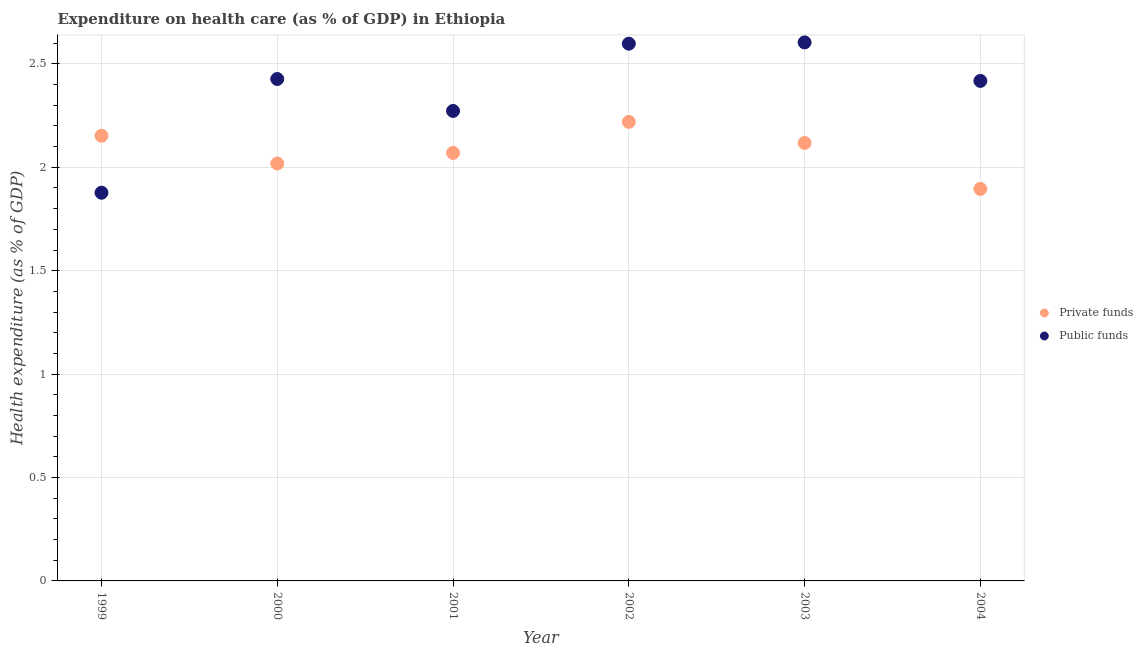Is the number of dotlines equal to the number of legend labels?
Provide a short and direct response. Yes. What is the amount of private funds spent in healthcare in 2003?
Your response must be concise. 2.12. Across all years, what is the maximum amount of private funds spent in healthcare?
Provide a short and direct response. 2.22. Across all years, what is the minimum amount of private funds spent in healthcare?
Your response must be concise. 1.9. In which year was the amount of private funds spent in healthcare maximum?
Offer a terse response. 2002. What is the total amount of private funds spent in healthcare in the graph?
Your answer should be compact. 12.47. What is the difference between the amount of private funds spent in healthcare in 1999 and that in 2004?
Keep it short and to the point. 0.26. What is the difference between the amount of public funds spent in healthcare in 2001 and the amount of private funds spent in healthcare in 2000?
Provide a succinct answer. 0.25. What is the average amount of private funds spent in healthcare per year?
Keep it short and to the point. 2.08. In the year 2002, what is the difference between the amount of public funds spent in healthcare and amount of private funds spent in healthcare?
Offer a very short reply. 0.38. What is the ratio of the amount of private funds spent in healthcare in 1999 to that in 2001?
Offer a terse response. 1.04. What is the difference between the highest and the second highest amount of private funds spent in healthcare?
Keep it short and to the point. 0.07. What is the difference between the highest and the lowest amount of private funds spent in healthcare?
Your response must be concise. 0.32. In how many years, is the amount of private funds spent in healthcare greater than the average amount of private funds spent in healthcare taken over all years?
Offer a terse response. 3. Is the sum of the amount of private funds spent in healthcare in 2001 and 2002 greater than the maximum amount of public funds spent in healthcare across all years?
Your answer should be very brief. Yes. Does the amount of private funds spent in healthcare monotonically increase over the years?
Offer a terse response. No. What is the difference between two consecutive major ticks on the Y-axis?
Offer a very short reply. 0.5. Does the graph contain grids?
Offer a terse response. Yes. How are the legend labels stacked?
Provide a succinct answer. Vertical. What is the title of the graph?
Offer a terse response. Expenditure on health care (as % of GDP) in Ethiopia. Does "Primary education" appear as one of the legend labels in the graph?
Provide a succinct answer. No. What is the label or title of the X-axis?
Keep it short and to the point. Year. What is the label or title of the Y-axis?
Offer a terse response. Health expenditure (as % of GDP). What is the Health expenditure (as % of GDP) of Private funds in 1999?
Offer a terse response. 2.15. What is the Health expenditure (as % of GDP) in Public funds in 1999?
Your response must be concise. 1.88. What is the Health expenditure (as % of GDP) in Private funds in 2000?
Keep it short and to the point. 2.02. What is the Health expenditure (as % of GDP) in Public funds in 2000?
Make the answer very short. 2.43. What is the Health expenditure (as % of GDP) in Private funds in 2001?
Your response must be concise. 2.07. What is the Health expenditure (as % of GDP) in Public funds in 2001?
Give a very brief answer. 2.27. What is the Health expenditure (as % of GDP) in Private funds in 2002?
Provide a short and direct response. 2.22. What is the Health expenditure (as % of GDP) of Public funds in 2002?
Provide a succinct answer. 2.6. What is the Health expenditure (as % of GDP) of Private funds in 2003?
Ensure brevity in your answer.  2.12. What is the Health expenditure (as % of GDP) in Public funds in 2003?
Provide a succinct answer. 2.6. What is the Health expenditure (as % of GDP) of Private funds in 2004?
Your answer should be compact. 1.9. What is the Health expenditure (as % of GDP) in Public funds in 2004?
Your response must be concise. 2.42. Across all years, what is the maximum Health expenditure (as % of GDP) in Private funds?
Your answer should be compact. 2.22. Across all years, what is the maximum Health expenditure (as % of GDP) of Public funds?
Your response must be concise. 2.6. Across all years, what is the minimum Health expenditure (as % of GDP) of Private funds?
Keep it short and to the point. 1.9. Across all years, what is the minimum Health expenditure (as % of GDP) of Public funds?
Provide a succinct answer. 1.88. What is the total Health expenditure (as % of GDP) in Private funds in the graph?
Provide a short and direct response. 12.47. What is the total Health expenditure (as % of GDP) in Public funds in the graph?
Offer a terse response. 14.2. What is the difference between the Health expenditure (as % of GDP) of Private funds in 1999 and that in 2000?
Provide a short and direct response. 0.13. What is the difference between the Health expenditure (as % of GDP) of Public funds in 1999 and that in 2000?
Provide a succinct answer. -0.55. What is the difference between the Health expenditure (as % of GDP) in Private funds in 1999 and that in 2001?
Provide a short and direct response. 0.08. What is the difference between the Health expenditure (as % of GDP) in Public funds in 1999 and that in 2001?
Keep it short and to the point. -0.4. What is the difference between the Health expenditure (as % of GDP) in Private funds in 1999 and that in 2002?
Your answer should be very brief. -0.07. What is the difference between the Health expenditure (as % of GDP) in Public funds in 1999 and that in 2002?
Your answer should be very brief. -0.72. What is the difference between the Health expenditure (as % of GDP) in Private funds in 1999 and that in 2003?
Provide a succinct answer. 0.03. What is the difference between the Health expenditure (as % of GDP) of Public funds in 1999 and that in 2003?
Your response must be concise. -0.73. What is the difference between the Health expenditure (as % of GDP) in Private funds in 1999 and that in 2004?
Your answer should be very brief. 0.26. What is the difference between the Health expenditure (as % of GDP) in Public funds in 1999 and that in 2004?
Your answer should be compact. -0.54. What is the difference between the Health expenditure (as % of GDP) of Private funds in 2000 and that in 2001?
Offer a terse response. -0.05. What is the difference between the Health expenditure (as % of GDP) of Public funds in 2000 and that in 2001?
Your response must be concise. 0.15. What is the difference between the Health expenditure (as % of GDP) of Private funds in 2000 and that in 2002?
Ensure brevity in your answer.  -0.2. What is the difference between the Health expenditure (as % of GDP) of Public funds in 2000 and that in 2002?
Offer a very short reply. -0.17. What is the difference between the Health expenditure (as % of GDP) of Private funds in 2000 and that in 2003?
Give a very brief answer. -0.1. What is the difference between the Health expenditure (as % of GDP) of Public funds in 2000 and that in 2003?
Make the answer very short. -0.18. What is the difference between the Health expenditure (as % of GDP) of Private funds in 2000 and that in 2004?
Make the answer very short. 0.12. What is the difference between the Health expenditure (as % of GDP) of Public funds in 2000 and that in 2004?
Provide a succinct answer. 0.01. What is the difference between the Health expenditure (as % of GDP) of Public funds in 2001 and that in 2002?
Offer a very short reply. -0.33. What is the difference between the Health expenditure (as % of GDP) of Private funds in 2001 and that in 2003?
Offer a very short reply. -0.05. What is the difference between the Health expenditure (as % of GDP) of Public funds in 2001 and that in 2003?
Provide a succinct answer. -0.33. What is the difference between the Health expenditure (as % of GDP) in Private funds in 2001 and that in 2004?
Give a very brief answer. 0.17. What is the difference between the Health expenditure (as % of GDP) of Public funds in 2001 and that in 2004?
Provide a short and direct response. -0.15. What is the difference between the Health expenditure (as % of GDP) in Private funds in 2002 and that in 2003?
Provide a short and direct response. 0.1. What is the difference between the Health expenditure (as % of GDP) of Public funds in 2002 and that in 2003?
Offer a terse response. -0.01. What is the difference between the Health expenditure (as % of GDP) of Private funds in 2002 and that in 2004?
Ensure brevity in your answer.  0.32. What is the difference between the Health expenditure (as % of GDP) in Public funds in 2002 and that in 2004?
Give a very brief answer. 0.18. What is the difference between the Health expenditure (as % of GDP) of Private funds in 2003 and that in 2004?
Provide a short and direct response. 0.22. What is the difference between the Health expenditure (as % of GDP) of Public funds in 2003 and that in 2004?
Your answer should be very brief. 0.19. What is the difference between the Health expenditure (as % of GDP) of Private funds in 1999 and the Health expenditure (as % of GDP) of Public funds in 2000?
Your answer should be very brief. -0.27. What is the difference between the Health expenditure (as % of GDP) in Private funds in 1999 and the Health expenditure (as % of GDP) in Public funds in 2001?
Your response must be concise. -0.12. What is the difference between the Health expenditure (as % of GDP) of Private funds in 1999 and the Health expenditure (as % of GDP) of Public funds in 2002?
Give a very brief answer. -0.45. What is the difference between the Health expenditure (as % of GDP) of Private funds in 1999 and the Health expenditure (as % of GDP) of Public funds in 2003?
Ensure brevity in your answer.  -0.45. What is the difference between the Health expenditure (as % of GDP) in Private funds in 1999 and the Health expenditure (as % of GDP) in Public funds in 2004?
Make the answer very short. -0.27. What is the difference between the Health expenditure (as % of GDP) of Private funds in 2000 and the Health expenditure (as % of GDP) of Public funds in 2001?
Keep it short and to the point. -0.25. What is the difference between the Health expenditure (as % of GDP) in Private funds in 2000 and the Health expenditure (as % of GDP) in Public funds in 2002?
Keep it short and to the point. -0.58. What is the difference between the Health expenditure (as % of GDP) of Private funds in 2000 and the Health expenditure (as % of GDP) of Public funds in 2003?
Offer a very short reply. -0.59. What is the difference between the Health expenditure (as % of GDP) in Private funds in 2000 and the Health expenditure (as % of GDP) in Public funds in 2004?
Your answer should be compact. -0.4. What is the difference between the Health expenditure (as % of GDP) of Private funds in 2001 and the Health expenditure (as % of GDP) of Public funds in 2002?
Give a very brief answer. -0.53. What is the difference between the Health expenditure (as % of GDP) in Private funds in 2001 and the Health expenditure (as % of GDP) in Public funds in 2003?
Your answer should be very brief. -0.53. What is the difference between the Health expenditure (as % of GDP) in Private funds in 2001 and the Health expenditure (as % of GDP) in Public funds in 2004?
Offer a very short reply. -0.35. What is the difference between the Health expenditure (as % of GDP) in Private funds in 2002 and the Health expenditure (as % of GDP) in Public funds in 2003?
Provide a short and direct response. -0.38. What is the difference between the Health expenditure (as % of GDP) of Private funds in 2002 and the Health expenditure (as % of GDP) of Public funds in 2004?
Give a very brief answer. -0.2. What is the average Health expenditure (as % of GDP) of Private funds per year?
Provide a succinct answer. 2.08. What is the average Health expenditure (as % of GDP) of Public funds per year?
Make the answer very short. 2.37. In the year 1999, what is the difference between the Health expenditure (as % of GDP) in Private funds and Health expenditure (as % of GDP) in Public funds?
Make the answer very short. 0.28. In the year 2000, what is the difference between the Health expenditure (as % of GDP) in Private funds and Health expenditure (as % of GDP) in Public funds?
Offer a terse response. -0.41. In the year 2001, what is the difference between the Health expenditure (as % of GDP) in Private funds and Health expenditure (as % of GDP) in Public funds?
Ensure brevity in your answer.  -0.2. In the year 2002, what is the difference between the Health expenditure (as % of GDP) in Private funds and Health expenditure (as % of GDP) in Public funds?
Your response must be concise. -0.38. In the year 2003, what is the difference between the Health expenditure (as % of GDP) of Private funds and Health expenditure (as % of GDP) of Public funds?
Ensure brevity in your answer.  -0.49. In the year 2004, what is the difference between the Health expenditure (as % of GDP) of Private funds and Health expenditure (as % of GDP) of Public funds?
Give a very brief answer. -0.52. What is the ratio of the Health expenditure (as % of GDP) of Private funds in 1999 to that in 2000?
Ensure brevity in your answer.  1.07. What is the ratio of the Health expenditure (as % of GDP) in Public funds in 1999 to that in 2000?
Ensure brevity in your answer.  0.77. What is the ratio of the Health expenditure (as % of GDP) in Public funds in 1999 to that in 2001?
Your answer should be compact. 0.83. What is the ratio of the Health expenditure (as % of GDP) of Private funds in 1999 to that in 2002?
Provide a succinct answer. 0.97. What is the ratio of the Health expenditure (as % of GDP) in Public funds in 1999 to that in 2002?
Ensure brevity in your answer.  0.72. What is the ratio of the Health expenditure (as % of GDP) in Private funds in 1999 to that in 2003?
Offer a very short reply. 1.02. What is the ratio of the Health expenditure (as % of GDP) of Public funds in 1999 to that in 2003?
Your answer should be very brief. 0.72. What is the ratio of the Health expenditure (as % of GDP) in Private funds in 1999 to that in 2004?
Keep it short and to the point. 1.14. What is the ratio of the Health expenditure (as % of GDP) of Public funds in 1999 to that in 2004?
Offer a terse response. 0.78. What is the ratio of the Health expenditure (as % of GDP) of Private funds in 2000 to that in 2001?
Your answer should be compact. 0.98. What is the ratio of the Health expenditure (as % of GDP) in Public funds in 2000 to that in 2001?
Keep it short and to the point. 1.07. What is the ratio of the Health expenditure (as % of GDP) in Private funds in 2000 to that in 2002?
Ensure brevity in your answer.  0.91. What is the ratio of the Health expenditure (as % of GDP) in Public funds in 2000 to that in 2002?
Ensure brevity in your answer.  0.93. What is the ratio of the Health expenditure (as % of GDP) in Private funds in 2000 to that in 2003?
Ensure brevity in your answer.  0.95. What is the ratio of the Health expenditure (as % of GDP) in Public funds in 2000 to that in 2003?
Offer a terse response. 0.93. What is the ratio of the Health expenditure (as % of GDP) of Private funds in 2000 to that in 2004?
Your answer should be very brief. 1.06. What is the ratio of the Health expenditure (as % of GDP) in Public funds in 2000 to that in 2004?
Keep it short and to the point. 1. What is the ratio of the Health expenditure (as % of GDP) in Private funds in 2001 to that in 2002?
Your answer should be very brief. 0.93. What is the ratio of the Health expenditure (as % of GDP) of Public funds in 2001 to that in 2002?
Keep it short and to the point. 0.87. What is the ratio of the Health expenditure (as % of GDP) of Private funds in 2001 to that in 2003?
Your response must be concise. 0.98. What is the ratio of the Health expenditure (as % of GDP) in Public funds in 2001 to that in 2003?
Ensure brevity in your answer.  0.87. What is the ratio of the Health expenditure (as % of GDP) in Private funds in 2001 to that in 2004?
Ensure brevity in your answer.  1.09. What is the ratio of the Health expenditure (as % of GDP) in Public funds in 2001 to that in 2004?
Your answer should be very brief. 0.94. What is the ratio of the Health expenditure (as % of GDP) in Private funds in 2002 to that in 2003?
Give a very brief answer. 1.05. What is the ratio of the Health expenditure (as % of GDP) of Public funds in 2002 to that in 2003?
Make the answer very short. 1. What is the ratio of the Health expenditure (as % of GDP) in Private funds in 2002 to that in 2004?
Your answer should be compact. 1.17. What is the ratio of the Health expenditure (as % of GDP) in Public funds in 2002 to that in 2004?
Keep it short and to the point. 1.07. What is the ratio of the Health expenditure (as % of GDP) of Private funds in 2003 to that in 2004?
Your answer should be very brief. 1.12. What is the ratio of the Health expenditure (as % of GDP) of Public funds in 2003 to that in 2004?
Keep it short and to the point. 1.08. What is the difference between the highest and the second highest Health expenditure (as % of GDP) in Private funds?
Offer a very short reply. 0.07. What is the difference between the highest and the second highest Health expenditure (as % of GDP) of Public funds?
Your response must be concise. 0.01. What is the difference between the highest and the lowest Health expenditure (as % of GDP) of Private funds?
Make the answer very short. 0.32. What is the difference between the highest and the lowest Health expenditure (as % of GDP) of Public funds?
Give a very brief answer. 0.73. 